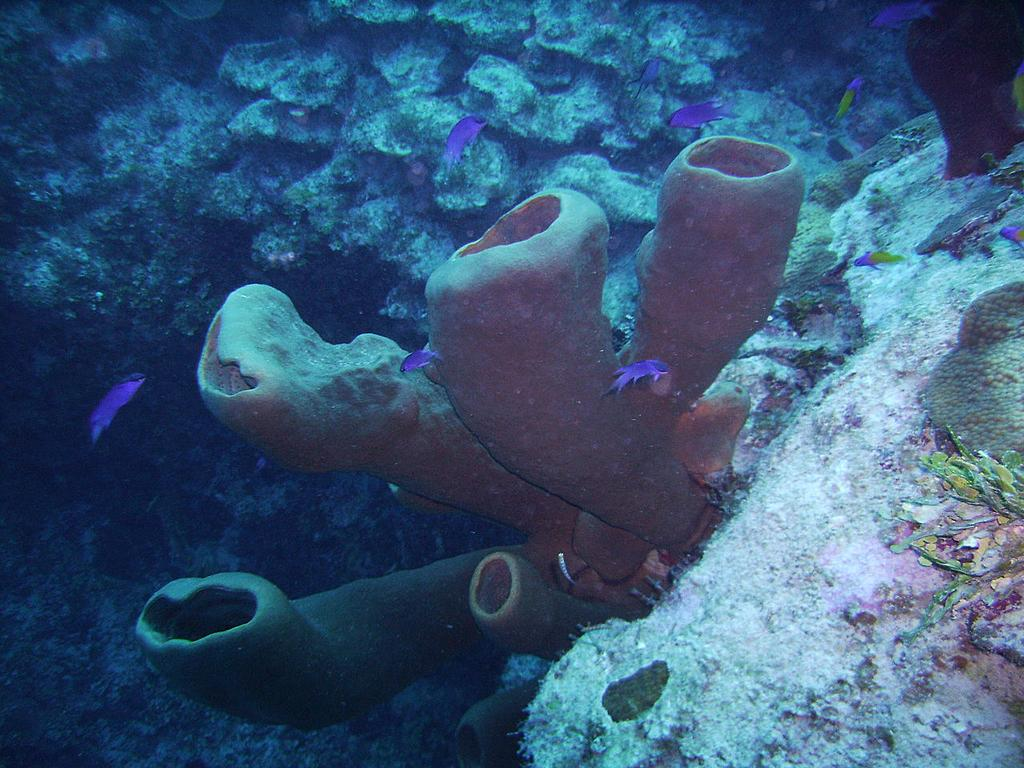What is located in the center of the image? There are plants and stones in the center of the image. What type of living organisms can be seen in the image? There are fish in the water. Are there any other objects in the water besides the fish? Yes, there are a few other objects in the water. What type of prison can be seen in the image? There is no prison present in the image. What is the yoke used for in the image? There is no yoke present in the image. 